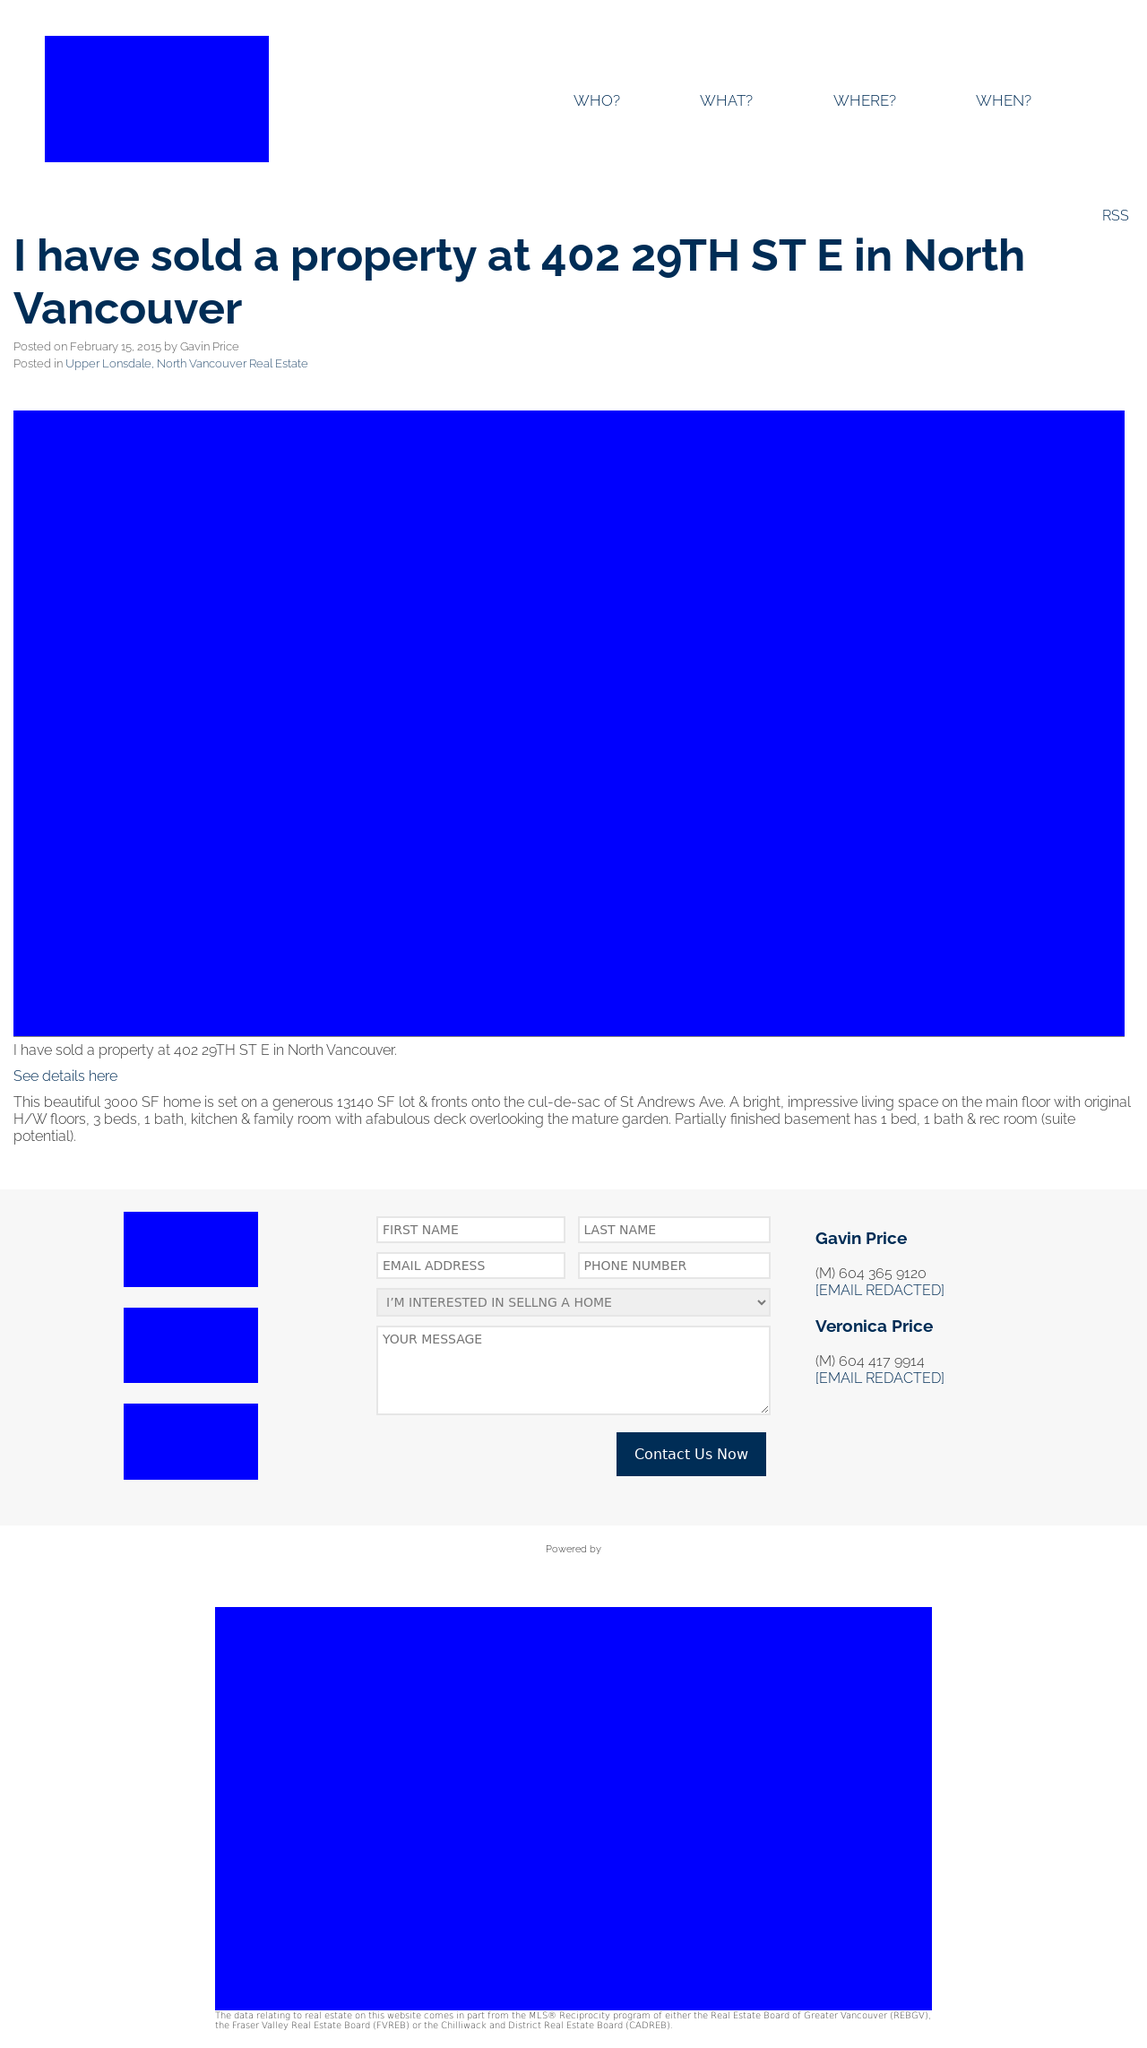What type of content is prominently featured on this website? The website prominently features real estate listings and related information. It seems designed to present properties for sale or rent, providing details about each listing directly on the homepage, along with options to contact real estate agents or browse more details.  Is there a way for users to interact directly with the listings on the homepage? Yes, users can interact with the listings through buttons or links for further information on each property. There are also likely forms integrated within the site, as suggested by the contact sections, where users can submit inquiries directly related to specific properties or general real estate questions. 